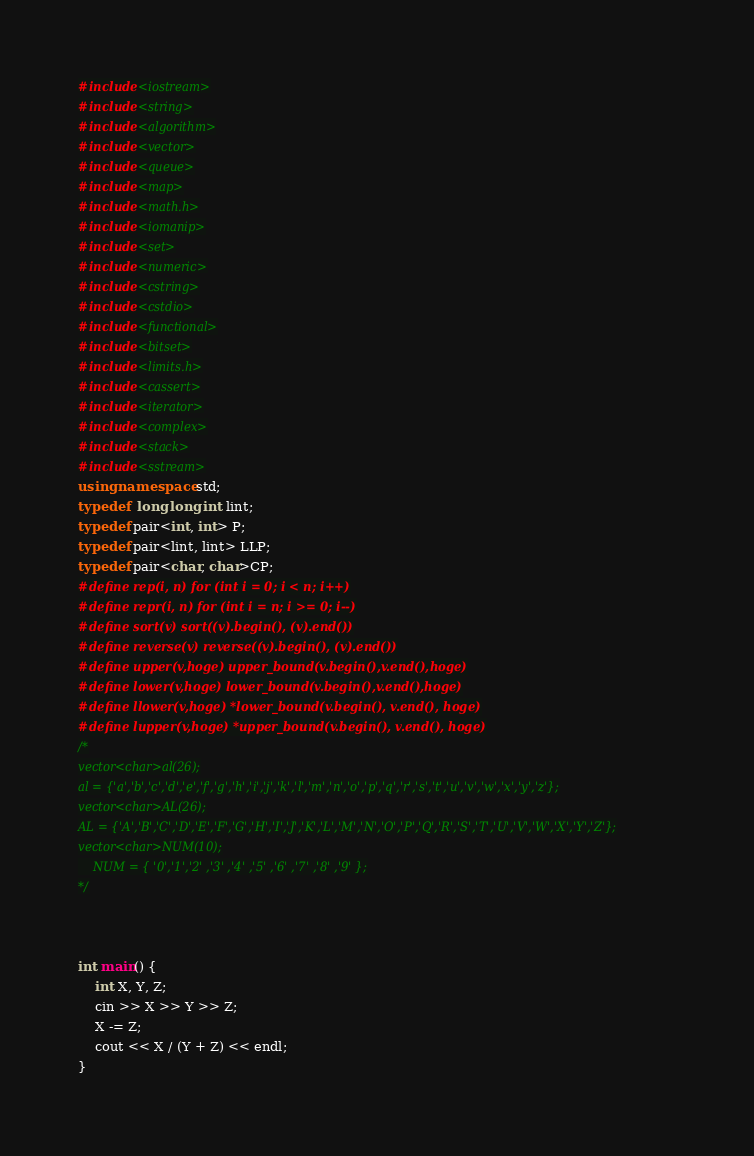<code> <loc_0><loc_0><loc_500><loc_500><_C++_>#include<iostream>
#include<string>
#include<algorithm>
#include<vector>
#include<queue>
#include<map>
#include<math.h>
#include<iomanip>
#include<set>
#include<numeric>
#include<cstring>
#include<cstdio>
#include<functional>
#include<bitset>
#include<limits.h>
#include<cassert>
#include<iterator>
#include<complex>
#include<stack>
#include<sstream>
using namespace std;
typedef  long long int lint;
typedef pair<int, int> P;
typedef pair<lint, lint> LLP;
typedef pair<char, char>CP;
#define rep(i, n) for (int i = 0; i < n; i++)
#define repr(i, n) for (int i = n; i >= 0; i--)
#define sort(v) sort((v).begin(), (v).end())
#define reverse(v) reverse((v).begin(), (v).end())
#define upper(v,hoge) upper_bound(v.begin(),v.end(),hoge)
#define lower(v,hoge) lower_bound(v.begin(),v.end(),hoge)
#define llower(v,hoge) *lower_bound(v.begin(), v.end(), hoge)
#define lupper(v,hoge) *upper_bound(v.begin(), v.end(), hoge)
/*
vector<char>al(26);
al = {'a','b','c','d','e','f','g','h','i','j','k','l','m','n','o','p','q','r','s','t','u','v','w','x','y','z'};
vector<char>AL(26);
AL = {'A','B','C','D','E','F','G','H','I','J','K','L','M','N','O','P','Q','R','S','T','U','V','W','X','Y','Z'};
vector<char>NUM(10);
	NUM = { '0','1','2' ,'3' ,'4' ,'5' ,'6' ,'7' ,'8' ,'9' };
*/



int main() {
	int X, Y, Z;
	cin >> X >> Y >> Z;
	X -= Z;
	cout << X / (Y + Z) << endl;
}</code> 